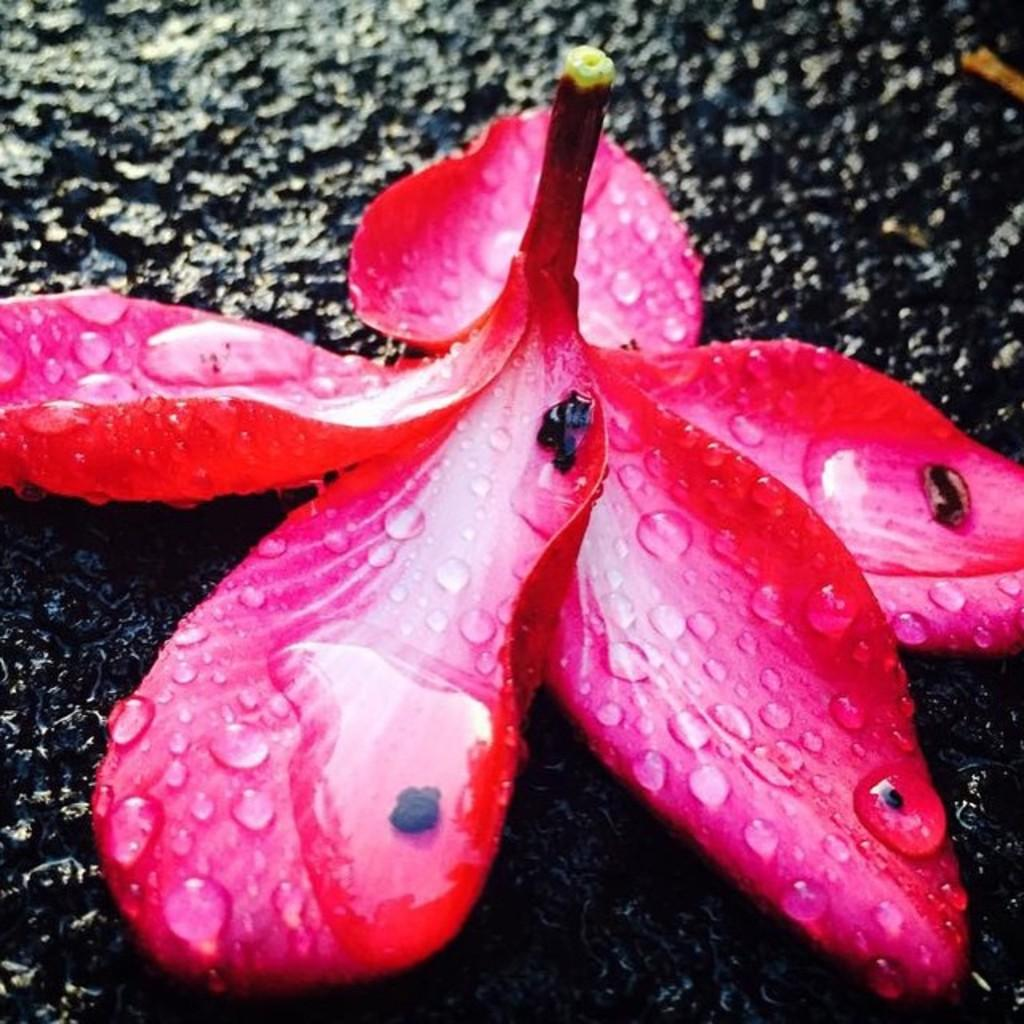What is the main subject of the image? There is a flower in the center of the image. What can be observed on the flower? There are water droplets on the flower. What is visible in the background of the image? There is a walkway in the background of the image. How many eyes can be seen on the flower in the image? There are no eyes present on the flower in the image. 